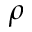<formula> <loc_0><loc_0><loc_500><loc_500>\rho</formula> 